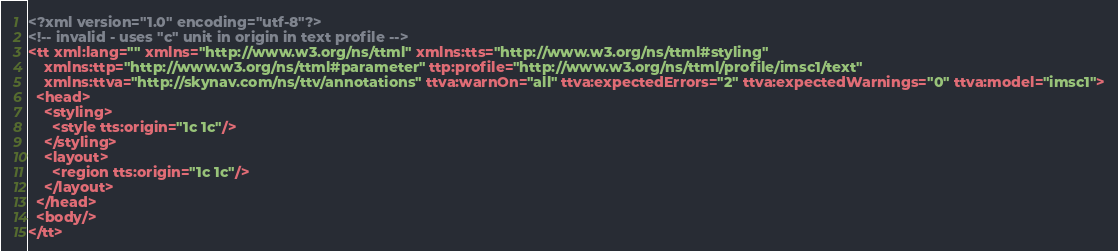Convert code to text. <code><loc_0><loc_0><loc_500><loc_500><_XML_><?xml version="1.0" encoding="utf-8"?>
<!-- invalid - uses "c" unit in origin in text profile -->
<tt xml:lang="" xmlns="http://www.w3.org/ns/ttml" xmlns:tts="http://www.w3.org/ns/ttml#styling"
    xmlns:ttp="http://www.w3.org/ns/ttml#parameter" ttp:profile="http://www.w3.org/ns/ttml/profile/imsc1/text"
    xmlns:ttva="http://skynav.com/ns/ttv/annotations" ttva:warnOn="all" ttva:expectedErrors="2" ttva:expectedWarnings="0" ttva:model="imsc1">
  <head>
    <styling>
      <style tts:origin="1c 1c"/>
    </styling>
    <layout>
      <region tts:origin="1c 1c"/>
    </layout>
  </head>
  <body/>
</tt>
</code> 